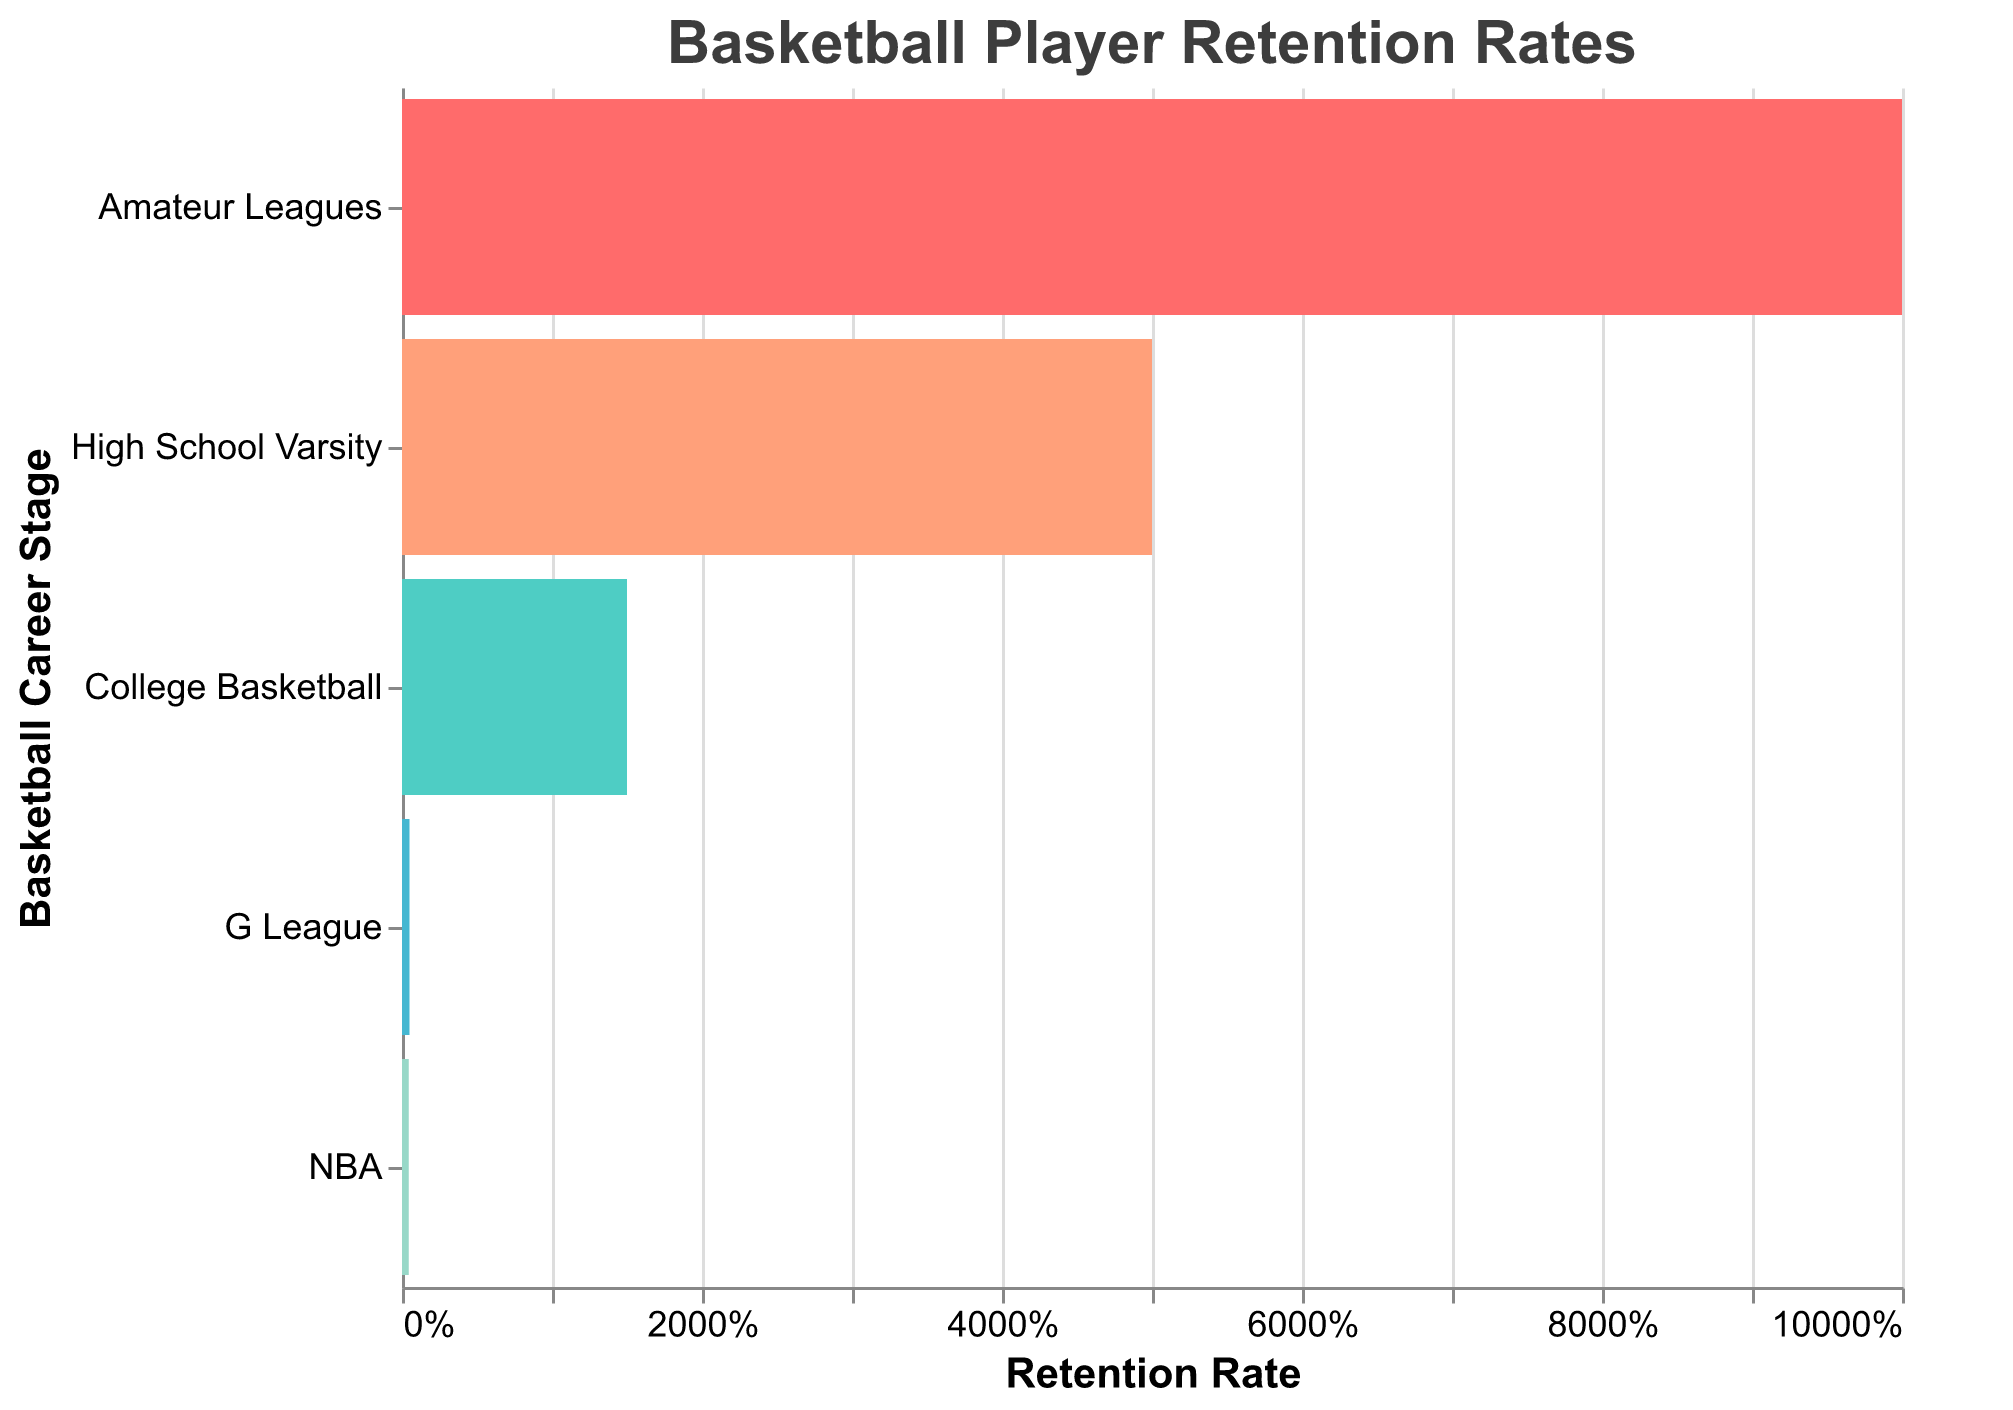What is the title of the chart? The title is displayed prominently at the top of the chart in a larger font size.
Answer: Basketball Player Retention Rates How many players remain at the G League stage? The chart shows a bar labeled "G League" and the exact number of remaining players.
Answer: 500 Which stage has the lowest percentage of players remaining? The bars are sorted in descending order by percentage. The NBA stage is at the bottom with the lowest percentage.
Answer: NBA What is the color of the bar representing the College Basketball stage? The bar's color for College Basketball can be observed directly from the chart.
Answer: #45B7D1 (color name or RGB) What is the difference in retention rate between High School Varsity and College Basketball stages? Subtract the retention rate of College Basketball (15%) from that of High School Varsity (50%).
Answer: 35% How many stages are shown in the chart? Counting the labeled stages on the y-axis gives the total number of stages.
Answer: Five stages Which stage has a higher retention rate, G League or NBA? Compare the percentage values next to the G League and NBA bars.
Answer: G League Is the retention percentage of High School Varsity greater than half of the Amateur Leagues' retention percentage? Calculate half of Amateur Leagues' 100% (which is 50%) and compare it to High School Varsity's 50%.
Answer: No What percentage of players make it from Amateur Leagues to High School Varsity? The second stage (High School Varsity) shows the percentage of players from the initial stage (Amateur Leagues).
Answer: 50% How does the relative drop in player numbers compare from the Amateur Leagues to College Basketball with the drop from College Basketball to G League? Subtract the player numbers: (100000 - 15000) for Amateur to College, and (15000 - 500) for College to G League.
Answer: 85000 to 14500 What stages show the most significant reduction in player retention rate? By visually comparing the gaps between the bars, the most substantial drops can be seen between the identified stages.
Answer: Amateur Leagues to High School Varsity, College Basketball to G League 